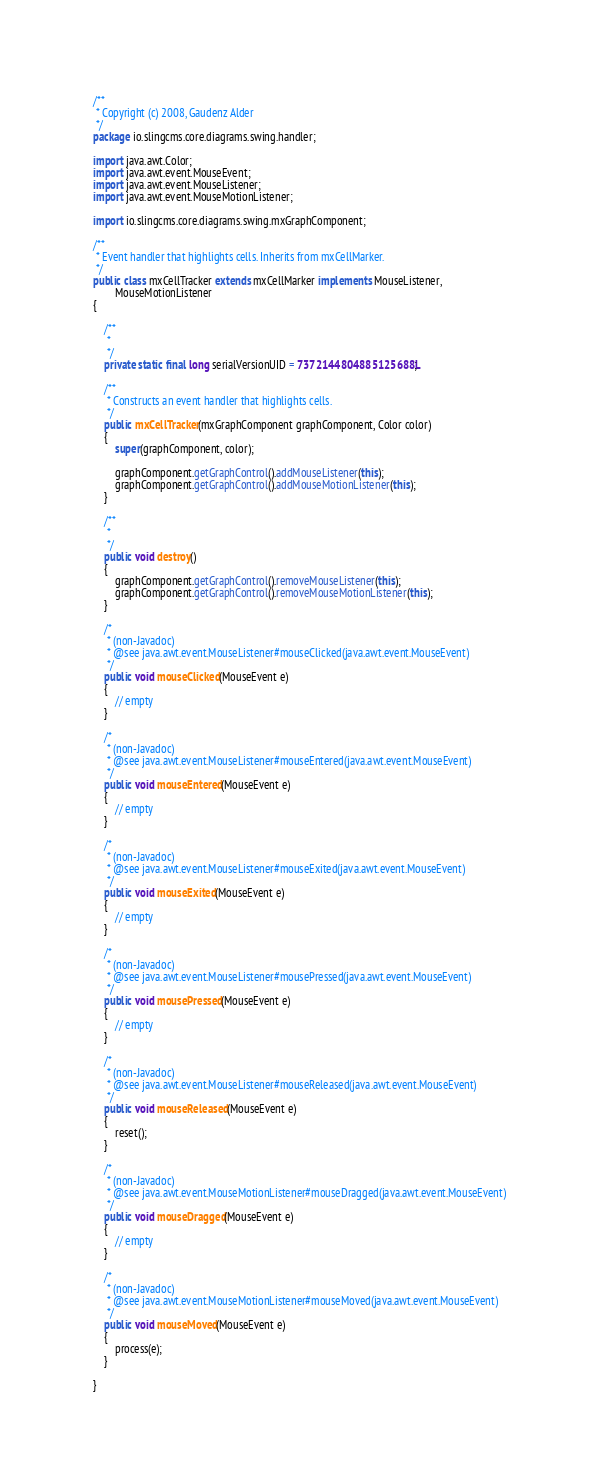Convert code to text. <code><loc_0><loc_0><loc_500><loc_500><_Java_>/**
 * Copyright (c) 2008, Gaudenz Alder
 */
package io.slingcms.core.diagrams.swing.handler;

import java.awt.Color;
import java.awt.event.MouseEvent;
import java.awt.event.MouseListener;
import java.awt.event.MouseMotionListener;

import io.slingcms.core.diagrams.swing.mxGraphComponent;

/**
 * Event handler that highlights cells. Inherits from mxCellMarker.
 */
public class mxCellTracker extends mxCellMarker implements MouseListener,
		MouseMotionListener
{

	/**
	 * 
	 */
	private static final long serialVersionUID = 7372144804885125688L;

	/**
	 * Constructs an event handler that highlights cells.
	 */
	public mxCellTracker(mxGraphComponent graphComponent, Color color)
	{
		super(graphComponent, color);

		graphComponent.getGraphControl().addMouseListener(this);
		graphComponent.getGraphControl().addMouseMotionListener(this);
	}

	/**
	 * 
	 */
	public void destroy()
	{
		graphComponent.getGraphControl().removeMouseListener(this);
		graphComponent.getGraphControl().removeMouseMotionListener(this);
	}

	/*
	 * (non-Javadoc)
	 * @see java.awt.event.MouseListener#mouseClicked(java.awt.event.MouseEvent)
	 */
	public void mouseClicked(MouseEvent e)
	{
		// empty
	}

	/*
	 * (non-Javadoc)
	 * @see java.awt.event.MouseListener#mouseEntered(java.awt.event.MouseEvent)
	 */
	public void mouseEntered(MouseEvent e)
	{
		// empty
	}

	/*
	 * (non-Javadoc)
	 * @see java.awt.event.MouseListener#mouseExited(java.awt.event.MouseEvent)
	 */
	public void mouseExited(MouseEvent e)
	{
		// empty
	}

	/*
	 * (non-Javadoc)
	 * @see java.awt.event.MouseListener#mousePressed(java.awt.event.MouseEvent)
	 */
	public void mousePressed(MouseEvent e)
	{
		// empty
	}

	/*
	 * (non-Javadoc)
	 * @see java.awt.event.MouseListener#mouseReleased(java.awt.event.MouseEvent)
	 */
	public void mouseReleased(MouseEvent e)
	{
		reset();
	}

	/*
	 * (non-Javadoc)
	 * @see java.awt.event.MouseMotionListener#mouseDragged(java.awt.event.MouseEvent)
	 */
	public void mouseDragged(MouseEvent e)
	{
		// empty
	}

	/*
	 * (non-Javadoc)
	 * @see java.awt.event.MouseMotionListener#mouseMoved(java.awt.event.MouseEvent)
	 */
	public void mouseMoved(MouseEvent e)
	{
		process(e);
	}

}
</code> 